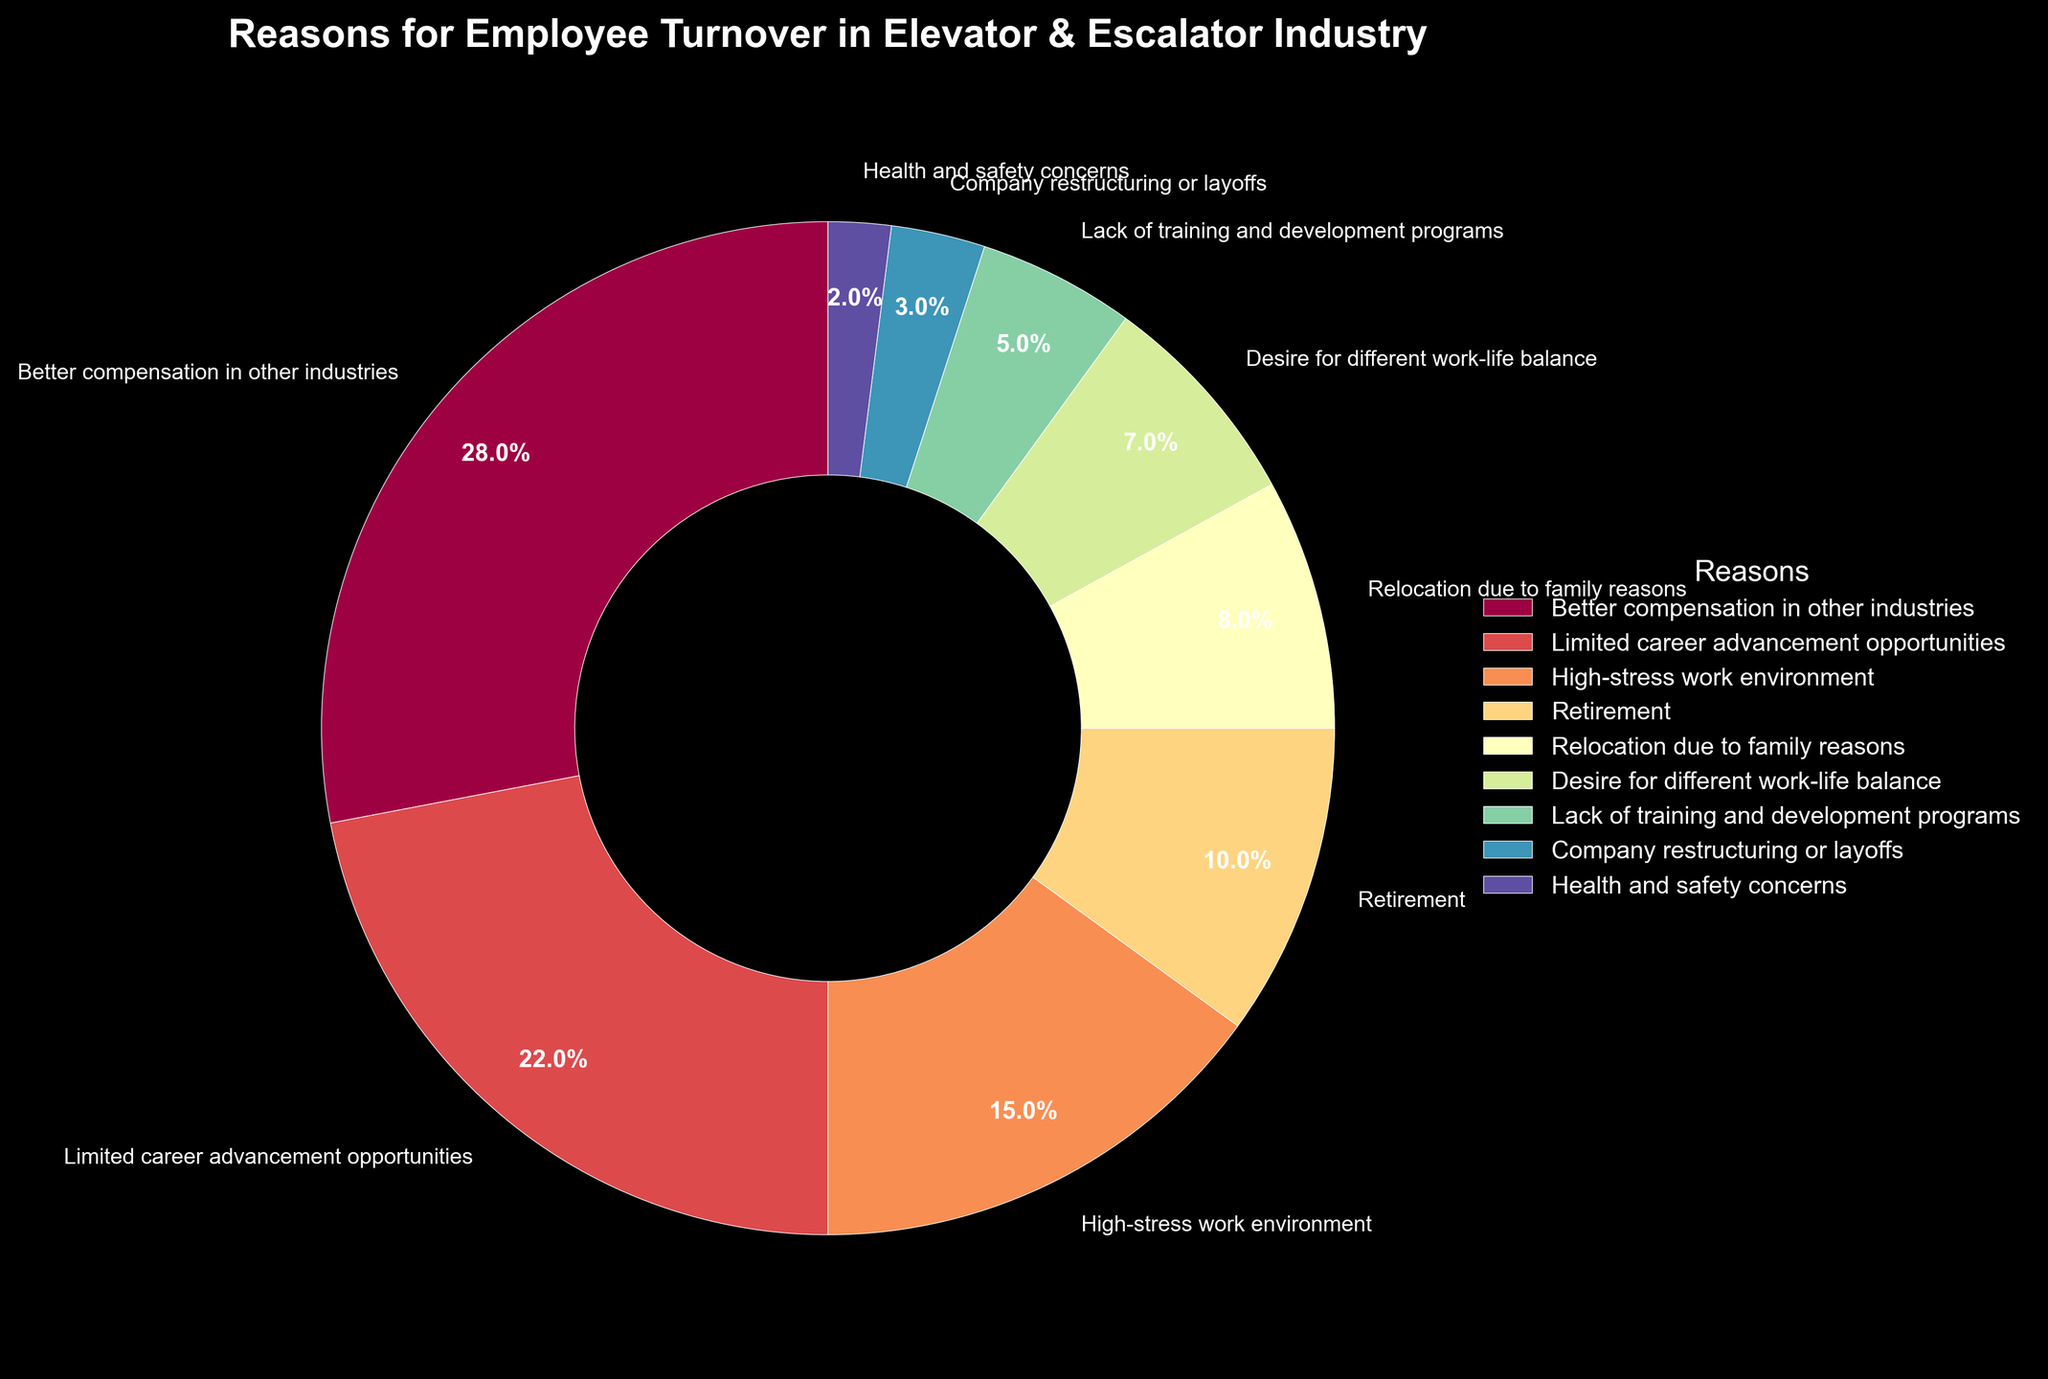Which is the most common reason for employee turnover in the Elevator & Escalator industry? The wedge with the largest percentage represents the most common reason. "Better compensation in other industries" has the largest share at 28%.
Answer: Better compensation in other industries What percentage of turnover is due to limited career advancement opportunities? Identify the wedge labeled "Limited career advancement opportunities" and read the corresponding percentage. It shows 22%.
Answer: 22% Which reason accounts for the smallest percentage of employee turnover? The smallest wedge in the pie chart signifies the lowest percentage. "Health and safety concerns" is the smallest at 2%.
Answer: Health and safety concerns How much more does "Better compensation in other industries" contribute to turnover compared to "Lack of training and development programs"? Subtract the percentage of "Lack of training and development programs" from "Better compensation in other industries" (28% - 5%).
Answer: 23% What is the combined percentage of turnover due to "Retirement" and "Relocation due to family reasons"? Add the percentages for "Retirement" and "Relocation due to family reasons" (10% + 8%).
Answer: 18% Is "High-stress work environment" a more or less common reason than "Desire for different work-life balance"? Compare the percentages of the two reasons. "High-stress work environment" is 15%, while "Desire for different work-life balance" is 7%, so it is more common.
Answer: More common If the reasons "Company restructuring or layoffs" and "Health and safety concerns" were combined, what would be their total percentage of turnover? Add the percentages of "Company restructuring or layoffs" and "Health and safety concerns" (3% + 2%).
Answer: 5% What visual characteristic helps identify the reason with the highest percentage? The wedge with the largest area and brightest segment usually represents the highest percentage in a pie chart. "Better compensation in other industries" has the largest and most distinct wedge.
Answer: Largest wedge 